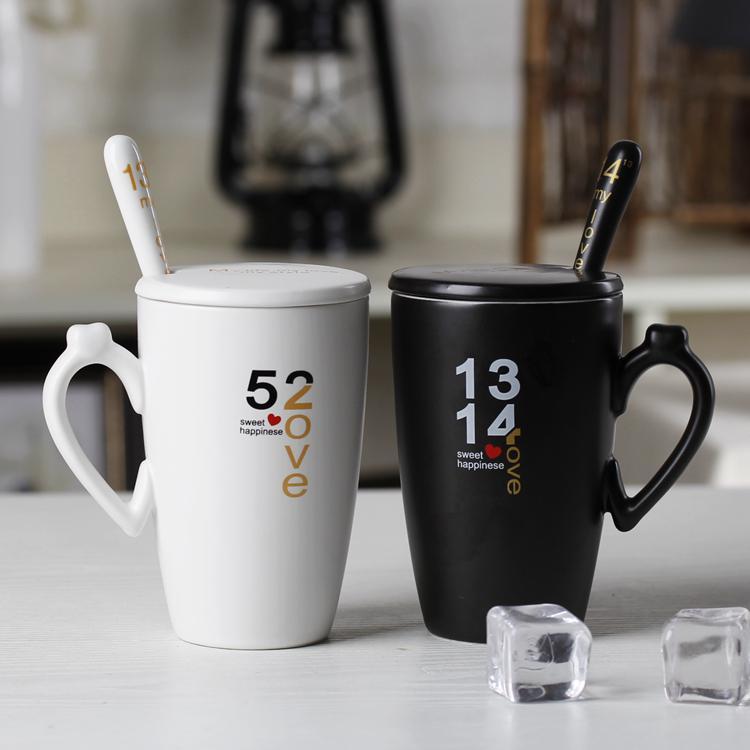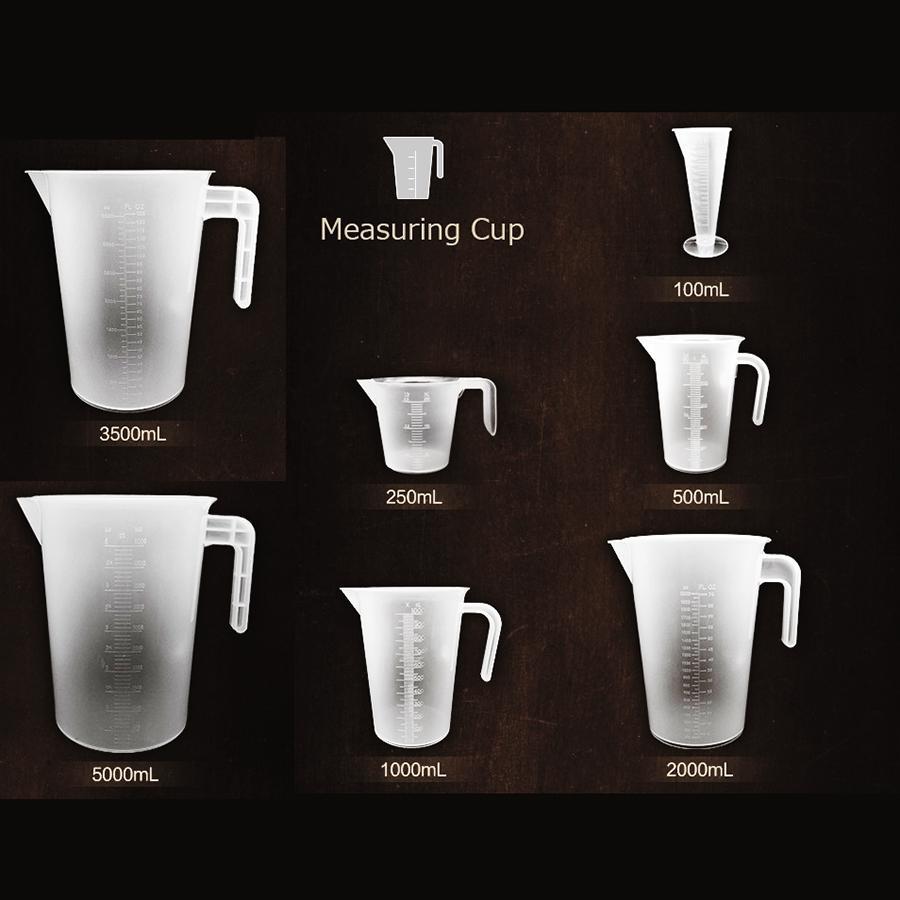The first image is the image on the left, the second image is the image on the right. Assess this claim about the two images: "In total, there are two cups and one spoon.". Correct or not? Answer yes or no. No. 